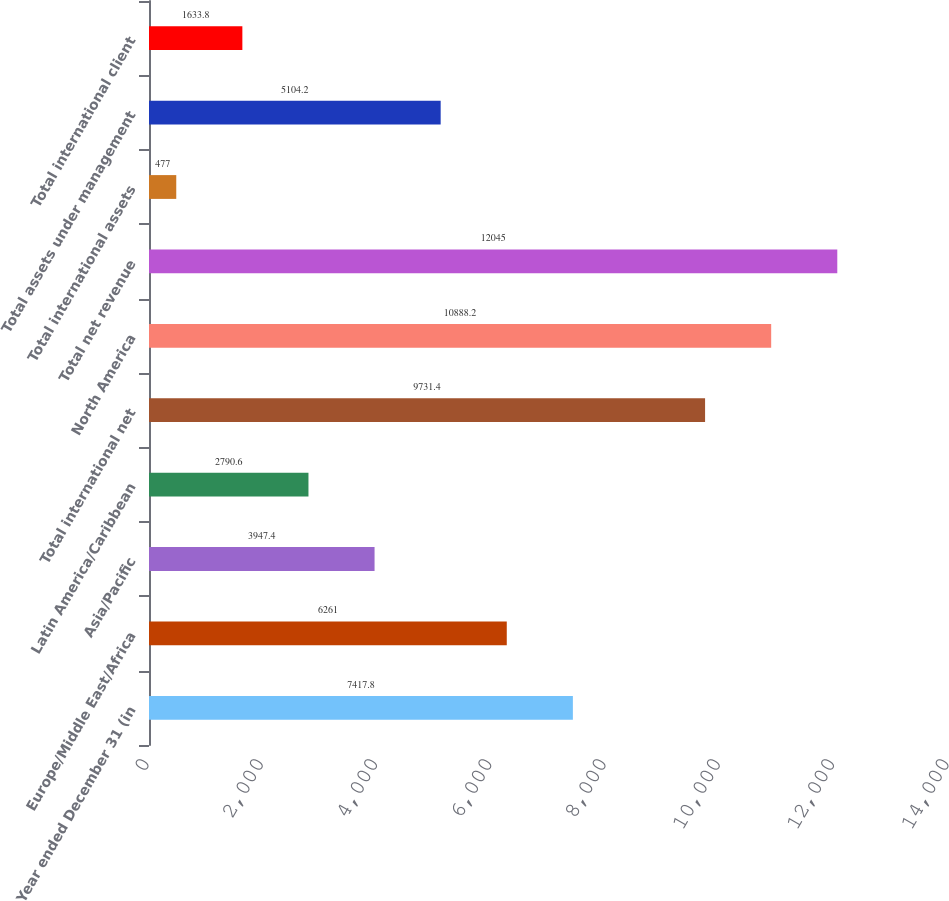Convert chart. <chart><loc_0><loc_0><loc_500><loc_500><bar_chart><fcel>Year ended December 31 (in<fcel>Europe/Middle East/Africa<fcel>Asia/Pacific<fcel>Latin America/Caribbean<fcel>Total international net<fcel>North America<fcel>Total net revenue<fcel>Total international assets<fcel>Total assets under management<fcel>Total international client<nl><fcel>7417.8<fcel>6261<fcel>3947.4<fcel>2790.6<fcel>9731.4<fcel>10888.2<fcel>12045<fcel>477<fcel>5104.2<fcel>1633.8<nl></chart> 